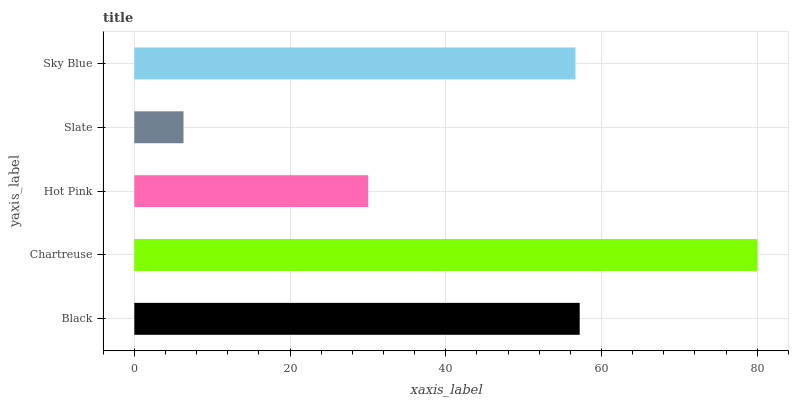Is Slate the minimum?
Answer yes or no. Yes. Is Chartreuse the maximum?
Answer yes or no. Yes. Is Hot Pink the minimum?
Answer yes or no. No. Is Hot Pink the maximum?
Answer yes or no. No. Is Chartreuse greater than Hot Pink?
Answer yes or no. Yes. Is Hot Pink less than Chartreuse?
Answer yes or no. Yes. Is Hot Pink greater than Chartreuse?
Answer yes or no. No. Is Chartreuse less than Hot Pink?
Answer yes or no. No. Is Sky Blue the high median?
Answer yes or no. Yes. Is Sky Blue the low median?
Answer yes or no. Yes. Is Black the high median?
Answer yes or no. No. Is Chartreuse the low median?
Answer yes or no. No. 